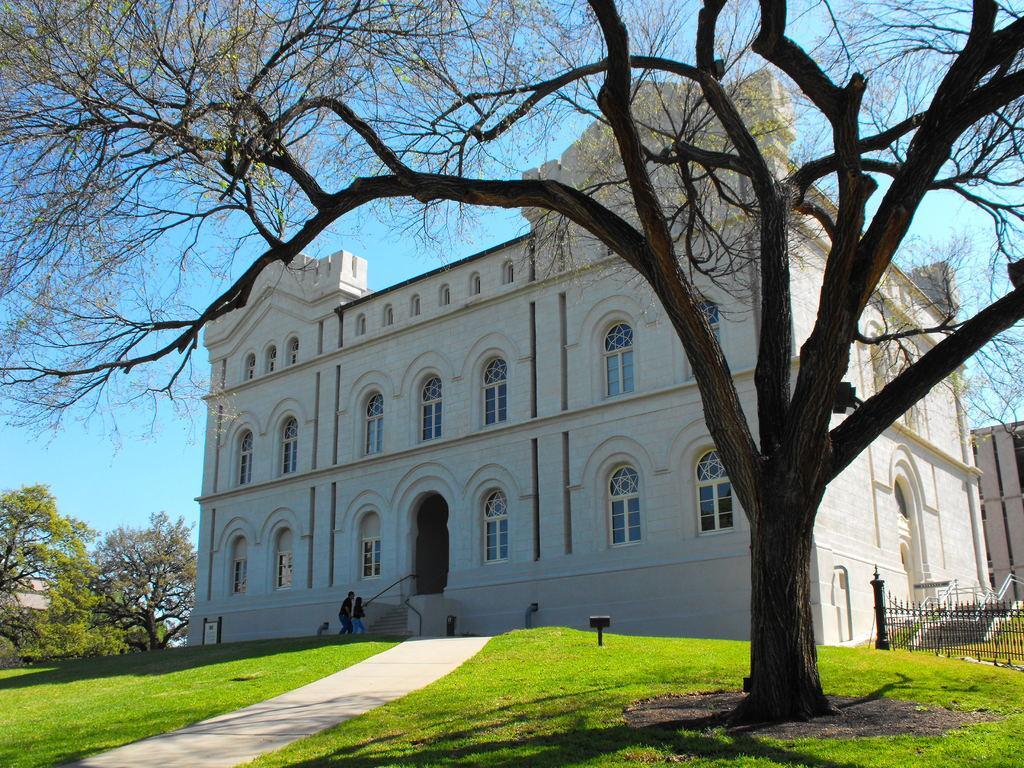Describe this image in one or two sentences. In this image we can see grass, fence, trees, and a building. There are two persons. In the background there is sky. 